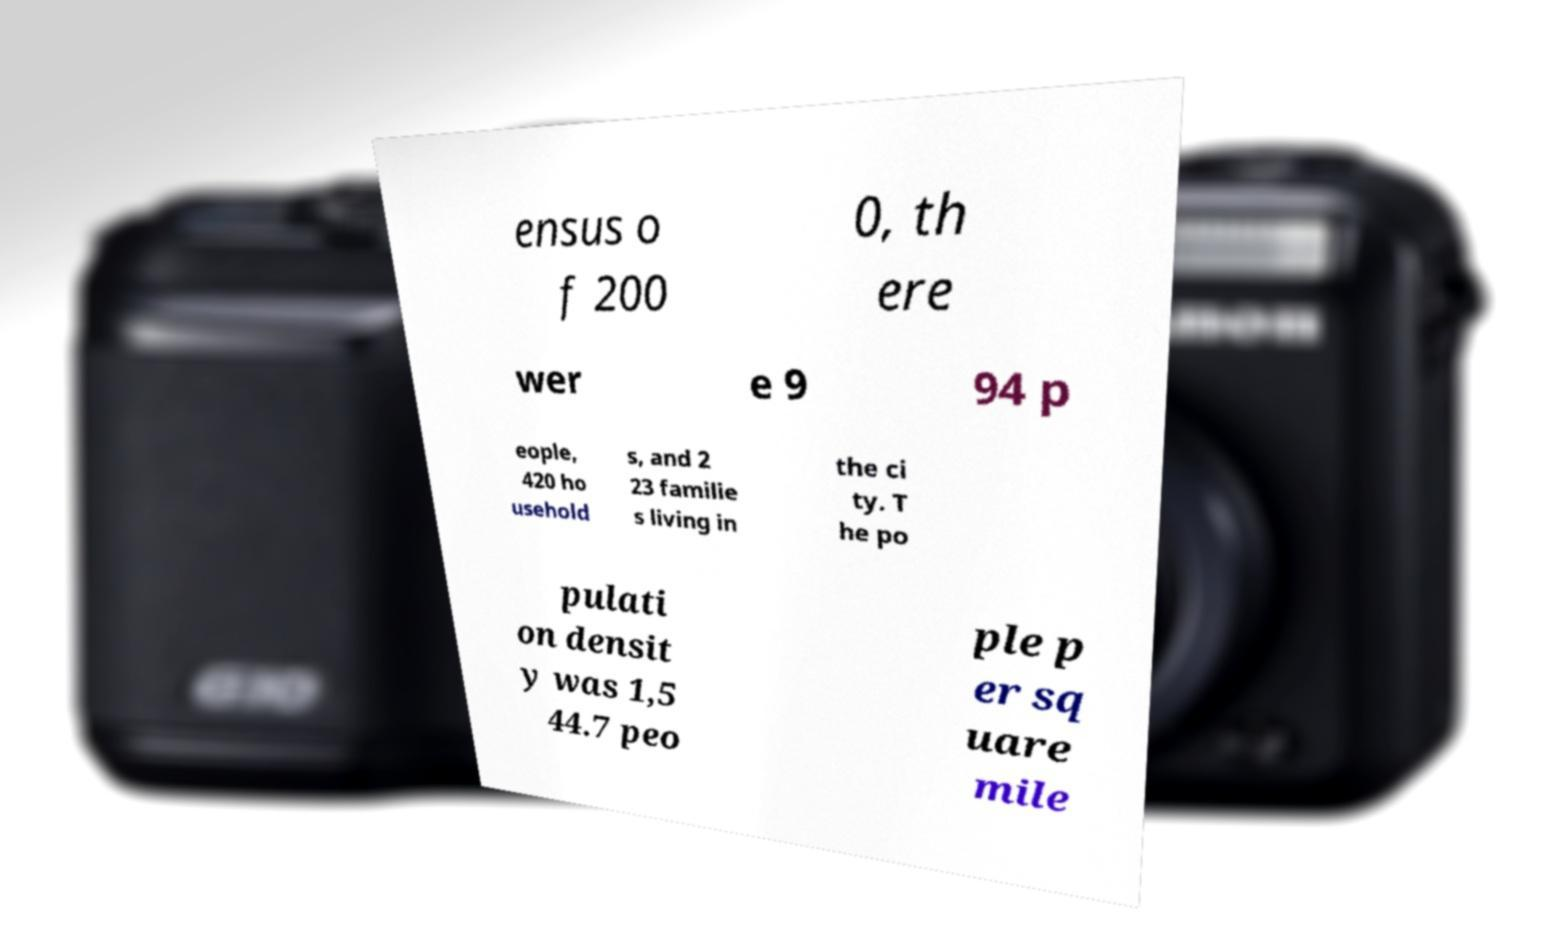Please identify and transcribe the text found in this image. ensus o f 200 0, th ere wer e 9 94 p eople, 420 ho usehold s, and 2 23 familie s living in the ci ty. T he po pulati on densit y was 1,5 44.7 peo ple p er sq uare mile 